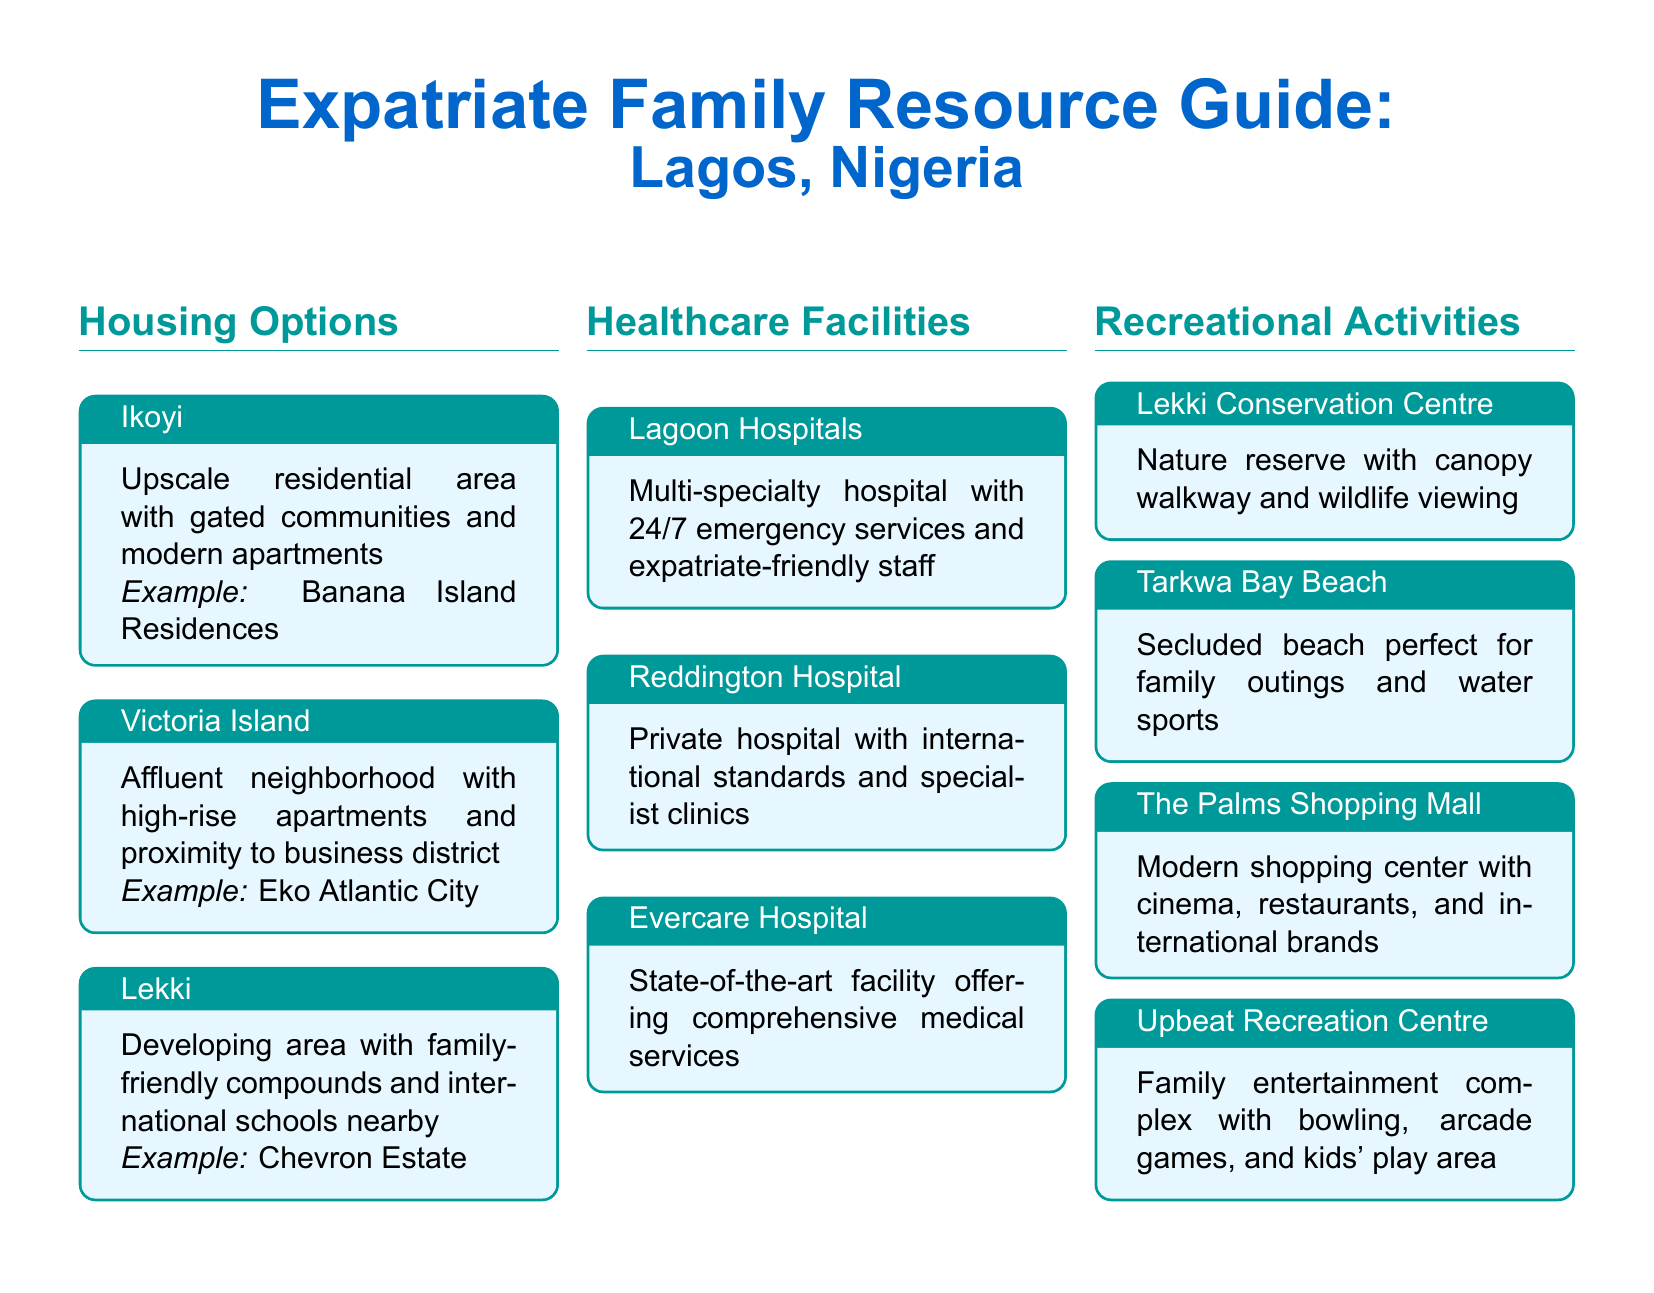What are the upscale residential areas mentioned? The document lists Ikoyi and Victoria Island as upscale residential areas.
Answer: Ikoyi, Victoria Island What type of hospital is Lagoon Hospitals? The document describes Lagoon Hospitals as a multi-specialty hospital.
Answer: Multi-specialty What is a recreational activity available at Lekki Conservation Centre? The document states that Lekki Conservation Centre offers a canopy walkway and wildlife viewing.
Answer: Canopy walkway Which area is suggested for family-friendly compounds? The document indicates Lekki as a developing area with family-friendly compounds.
Answer: Lekki What is the feature of Tarkwa Bay Beach? The document describes Tarkwa Bay Beach as a secluded beach perfect for family outings and water sports.
Answer: Secluded beach Which shopping mall is mentioned in the document? The document lists The Palms Shopping Mall as a modern shopping center.
Answer: The Palms Shopping Mall How many healthcare facilities are listed in the document? The document lists three healthcare facilities under the Healthcare Facilities section.
Answer: Three What type of entertainment does Upbeat Recreation Centre provide? The document states that Upbeat Recreation Centre offers a family entertainment complex with bowling, arcade games, and kids' play area.
Answer: Family entertainment complex 